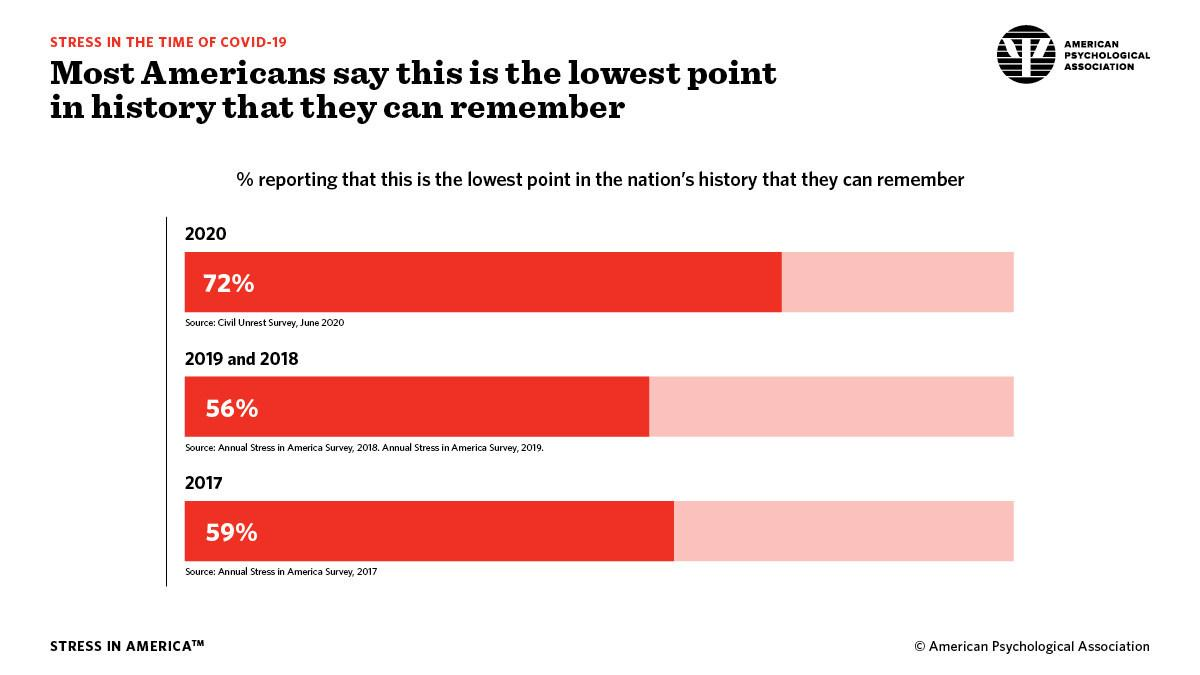Indicate a few pertinent items in this graphic. It is estimated that 41% of Americans disagree that 2017 is the lowest point in history. According to a recent survey, 28% of Americans disagree that 2020 is the lowest point in history. According to a recent survey, 44% of Americans disagree that 2019 and 2018 are the lowest point in history. 